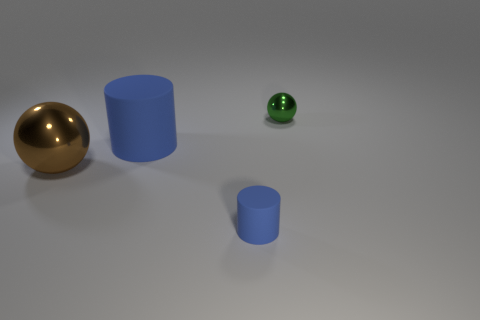What do the sizes and positions of the objects suggest? The varying sizes and positions could suggest a perspective exercise, with the smaller objects placed further back to give an illusion of depth, or it might imply a narrative of scale, with each object's size giving it a sense of importance or hierarchy. 